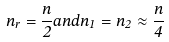<formula> <loc_0><loc_0><loc_500><loc_500>n _ { r } = \frac { n } { 2 } a n d n _ { 1 } = n _ { 2 } \approx \frac { n } { 4 }</formula> 